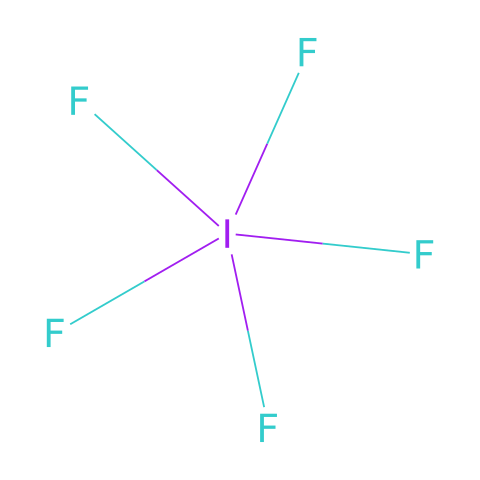What is the total number of fluorine atoms in iodine pentafluoride? The SMILES representation shows five fluorine atoms bonded to a single iodine atom, indicated by the "F" before and after the iodine notation.
Answer: five How many bonds are present in iodine pentafluoride? Each of the five fluorine atoms forms a single bond with the iodine atom, resulting in a total of five bonds.
Answer: five What type of hybridization does the iodine atom exhibit in iodine pentafluoride? The iodine atom is surrounded by five fluorine atoms, indicating sp3d hybridization, which is characteristic of hypervalent compounds.
Answer: sp3d Is iodine pentafluoride a polar chemical compound? The unequal distribution of electrons due to the electronegativity difference between iodine and fluorine leads to the overall polarity of the molecule.
Answer: yes What is the maximum number of valence electrons surrounding the iodine atom in iodine pentafluoride? The iodine atom has seven valence electrons normally, but in this configuration as a hypervalent compound, it can accommodate more, specifically five bonds with fluorine adding more effective electron pairing, totaling ten.
Answer: ten What characteristic makes iodine pentafluoride hypervalent? Hypervalent compounds possess central atoms that exceed the octet rule; here, iodine exhibits this by bonding with five fluorine atoms.
Answer: exceeding octet 